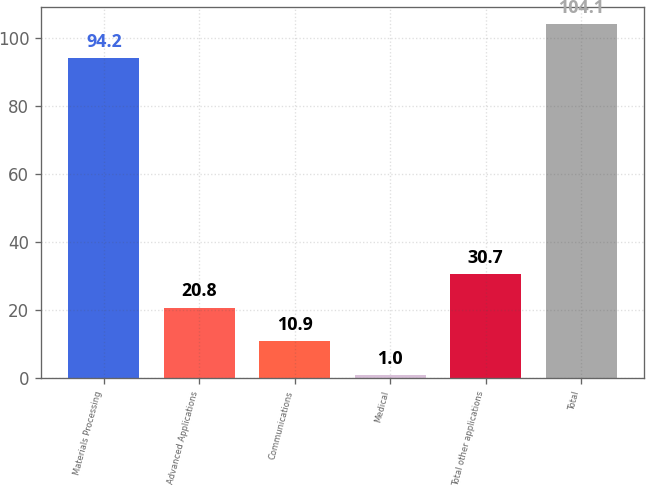<chart> <loc_0><loc_0><loc_500><loc_500><bar_chart><fcel>Materials Processing<fcel>Advanced Applications<fcel>Communications<fcel>Medical<fcel>Total other applications<fcel>Total<nl><fcel>94.2<fcel>20.8<fcel>10.9<fcel>1<fcel>30.7<fcel>104.1<nl></chart> 